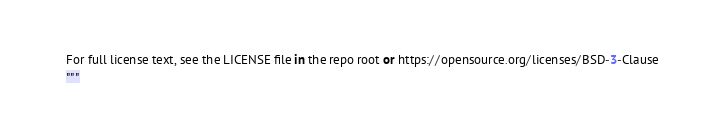Convert code to text. <code><loc_0><loc_0><loc_500><loc_500><_Python_>For full license text, see the LICENSE file in the repo root or https://opensource.org/licenses/BSD-3-Clause
"""

</code> 